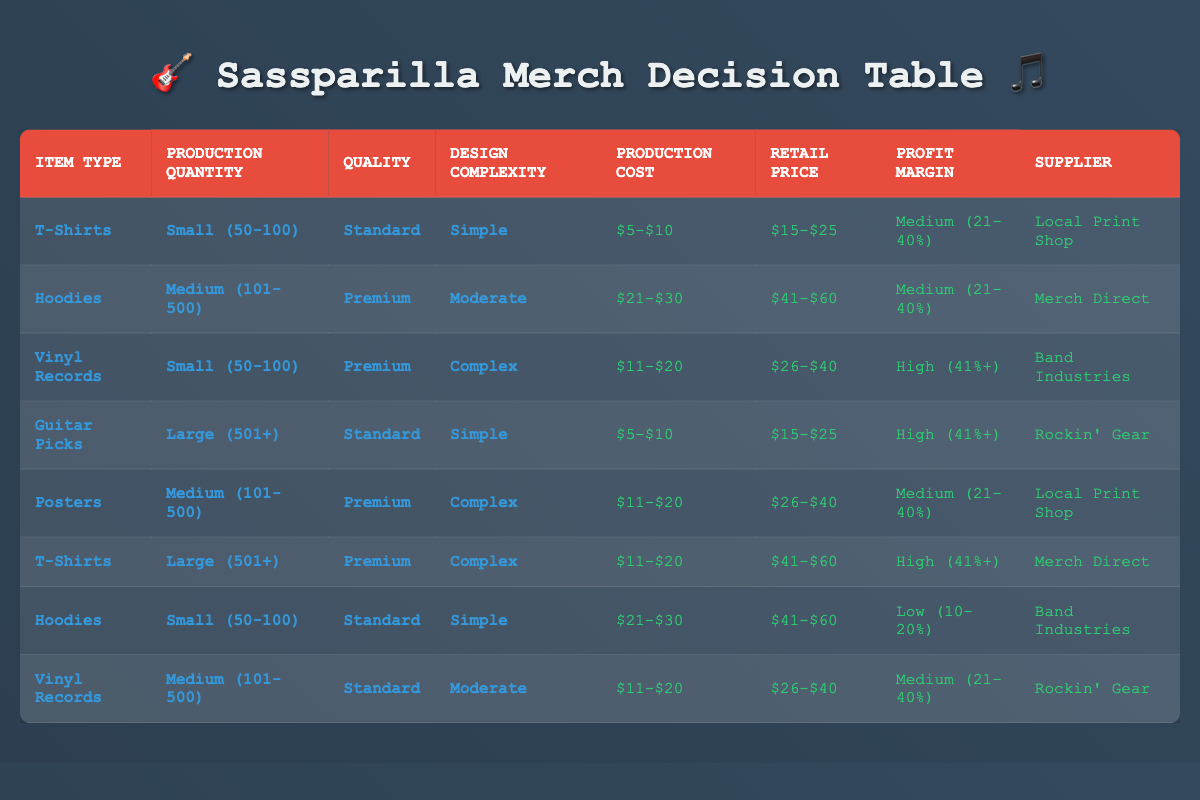What is the production cost for vinyl records that have a premium quality and complex design? The specific row for vinyl records with premium quality and complex design lists the production cost as $11-$20.
Answer: $11-$20 How many different suppliers are listed in the table? There are four unique suppliers: Local Print Shop, Merch Direct, Band Industries, and Rockin' Gear. Counting these gives us a total of four suppliers.
Answer: 4 What is the profit margin for t-shirts produced in large quantity and with a premium quality? Referring to the t-shirts row with large quantity and premium quality shows a profit margin of high (41%+).
Answer: High (41%+) Are the guitar picks produced in large quantity listed with a low profit margin? The row for guitar picks in large quantity indicates a profit margin of high (41+%), therefore the statement is false.
Answer: No What is the average retail price range for hoodies, whether they are premium or standard quality? There are two rows for hoodies: one with range $41-$60 (premium) and another with $41-$60 (standard). Both rows have the same range, so the average is $41-$60.
Answer: $41-$60 Which item type has the highest profit margin in the table? Looking at all rows, vinyl records have the highest profit margin listed as high (41%+), while other item types have lower margins.
Answer: Vinyl Records How many t-shirt options are listed in the table that have a medium profit margin? There is only one row for t-shirts with a medium profit margin, which corresponds to the setup of standard quality in a small quantity.
Answer: 1 Is there a row for posters that lists a local print shop as a supplier? Yes, the row for posters has local print shop listed as the supplier.
Answer: Yes 